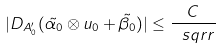<formula> <loc_0><loc_0><loc_500><loc_500>| D _ { A _ { 0 } ^ { \prime } } ( \tilde { \alpha _ { 0 } } \otimes u _ { 0 } + \tilde { \beta _ { 0 } } ) | \leq \frac { C } { \ s q r r }</formula> 